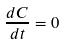<formula> <loc_0><loc_0><loc_500><loc_500>\frac { d C } { d t } = 0</formula> 